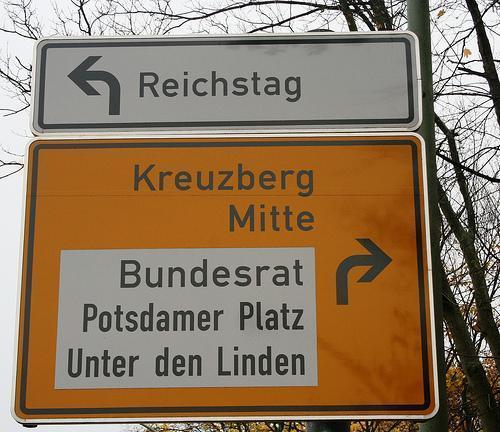How many signs are there?
Give a very brief answer. 2. 